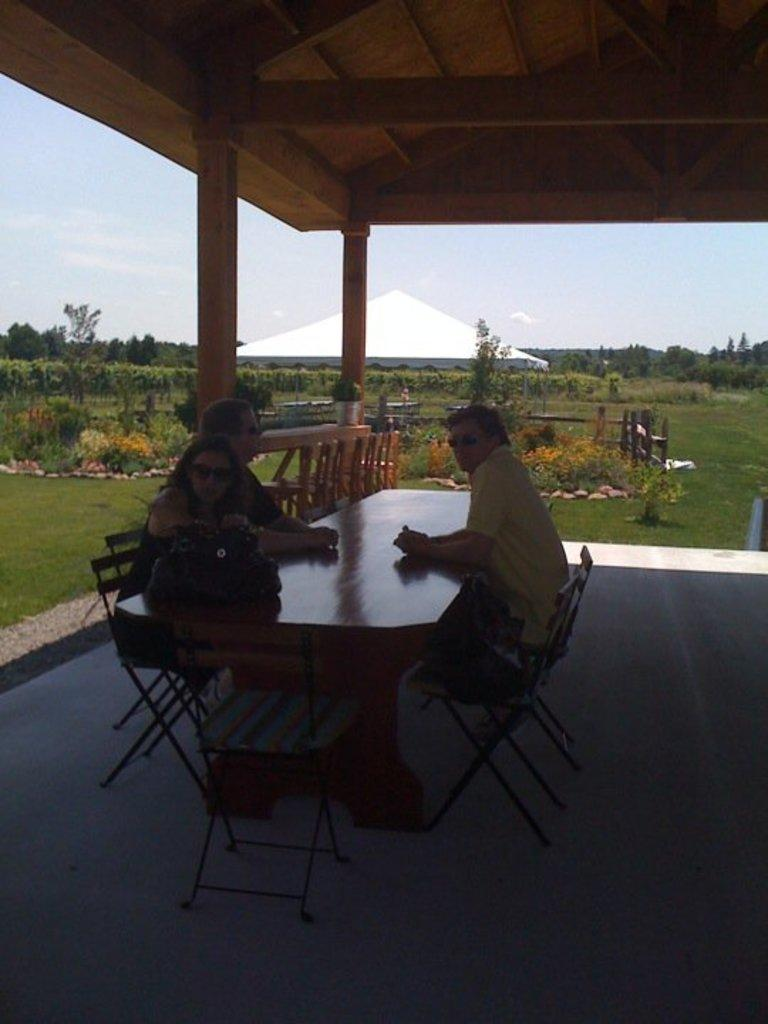What are the people in the image doing? The people in the image are sitting in chairs. Where are the people located in relation to the table? The people are in front of a table. What can be seen behind the people in the image? There is a beautiful garden behind the people. What type of cattle can be seen in the image? There are no cattle present in the image. The image features people sitting in chairs in front of a table, with a beautiful garden visible behind them. 